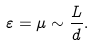<formula> <loc_0><loc_0><loc_500><loc_500>\varepsilon = \mu \sim \frac { L } { d } .</formula> 